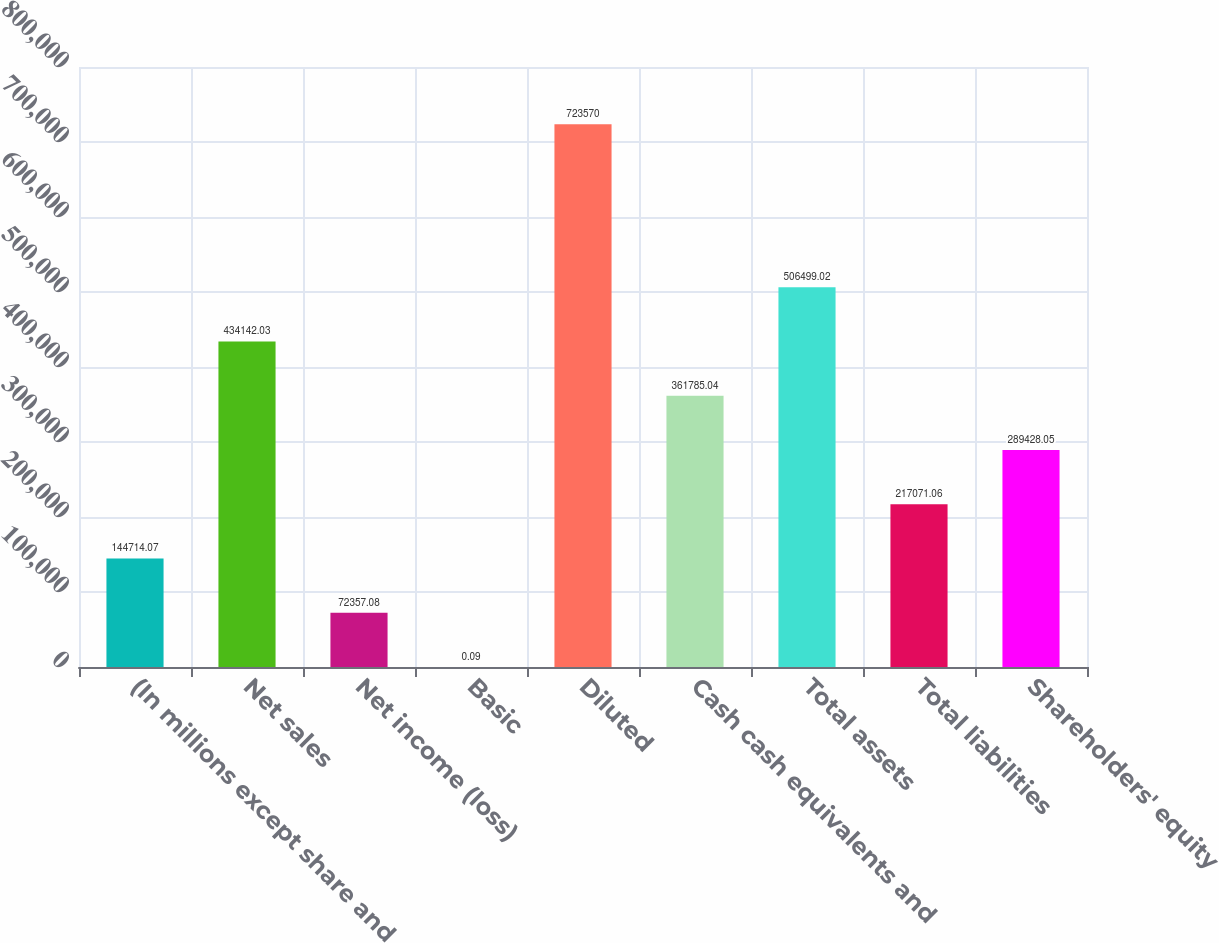Convert chart to OTSL. <chart><loc_0><loc_0><loc_500><loc_500><bar_chart><fcel>(In millions except share and<fcel>Net sales<fcel>Net income (loss)<fcel>Basic<fcel>Diluted<fcel>Cash cash equivalents and<fcel>Total assets<fcel>Total liabilities<fcel>Shareholders' equity<nl><fcel>144714<fcel>434142<fcel>72357.1<fcel>0.09<fcel>723570<fcel>361785<fcel>506499<fcel>217071<fcel>289428<nl></chart> 